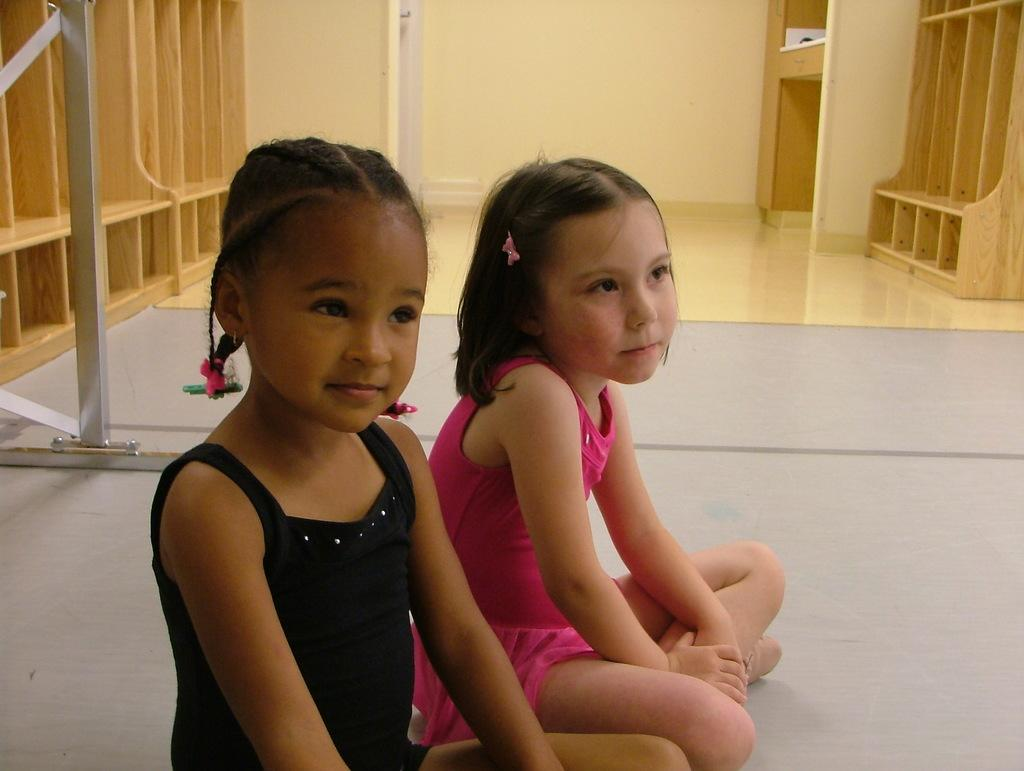How many girls are sitting on the floor in the image? There are two girls sitting on the floor in the image. What objects can be seen in the image besides the girls? There are rods and wooden racks visible in the image. What is the background of the image? There is a wall in the image. What month is it in the image? The month is not mentioned or depicted in the image. What type of fork is being used by the girls in the image? There are no forks present in the image. 